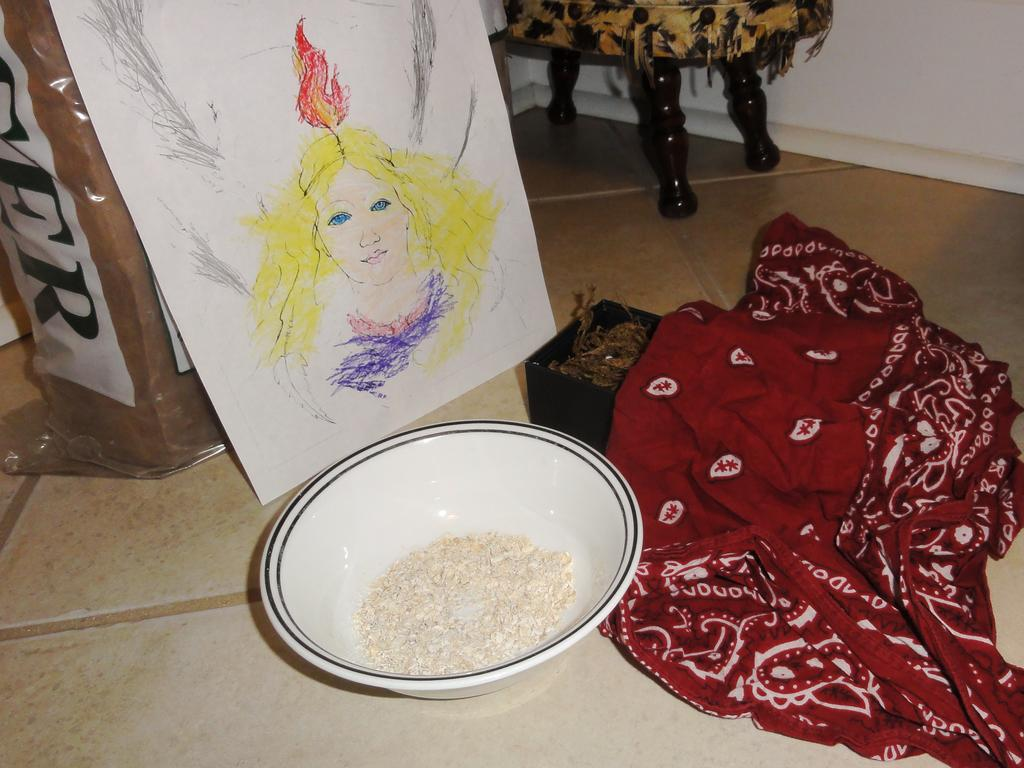What is the color of the wall in the image? The wall in the image is white. What is covering the table in the image? There is a tablecloth in the image. What can be seen on the tablecloth? There is a drawing in the image. What type of potato is being used to create the drawing in the image? There is no potato present in the image, and the drawing is not being created with a potato. 